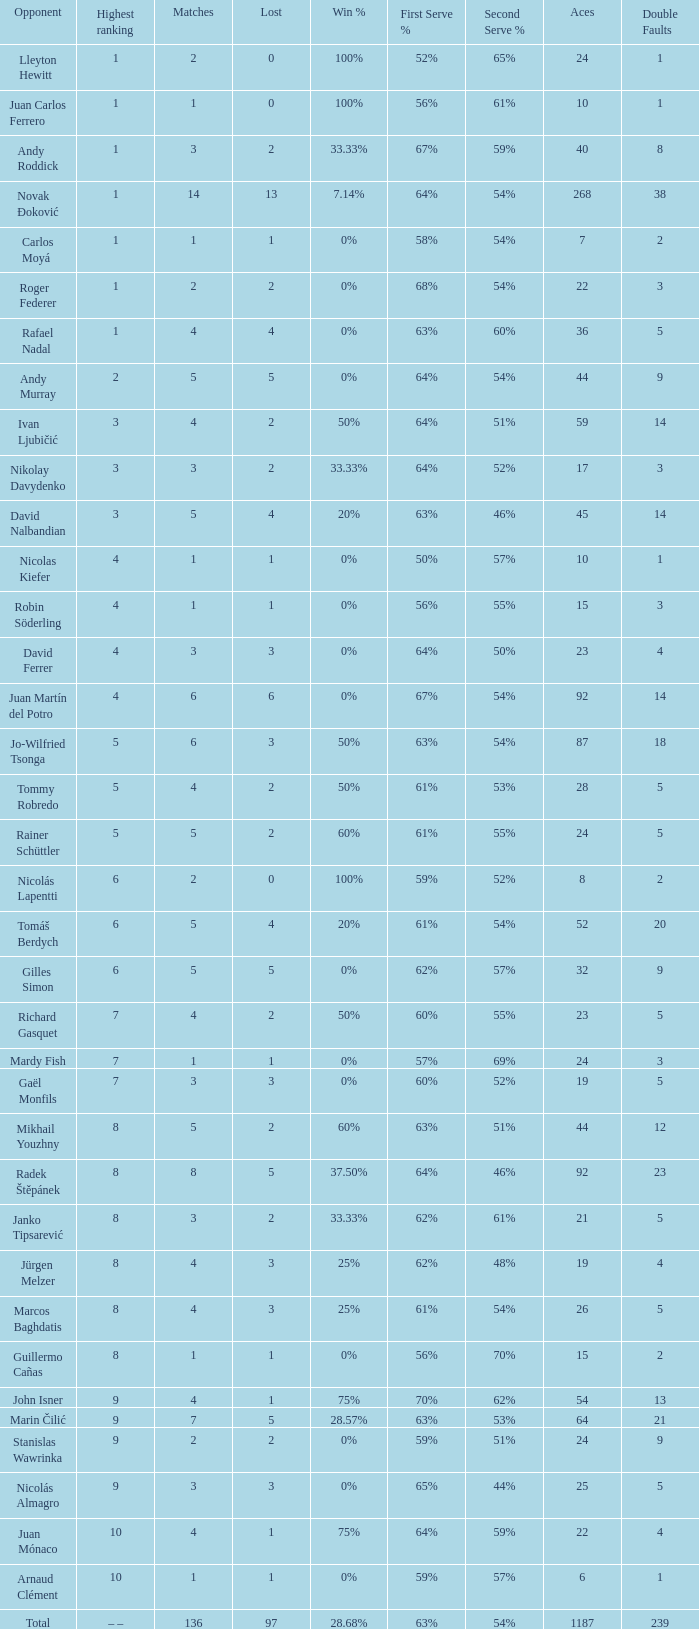What is the largest number Lost to david nalbandian with a Win Rate of 20%? 4.0. 